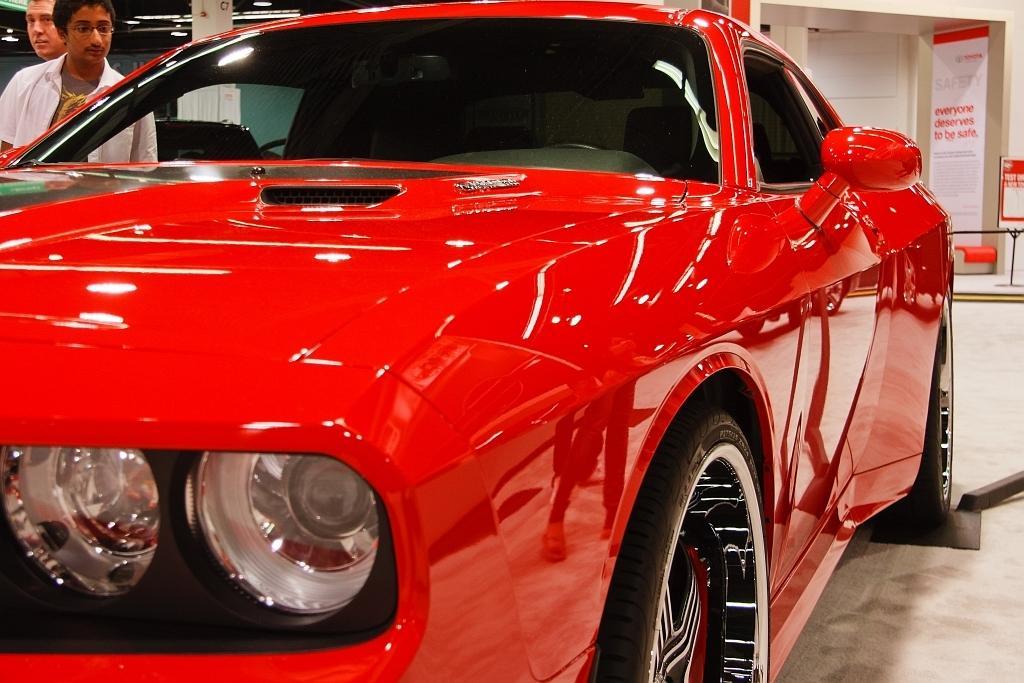In one or two sentences, can you explain what this image depicts? In this image I can see a red color car and I can see two persons standing in the top left corner. I can see some lights behind them I can see a banner and a board with some text in the top right corner. 